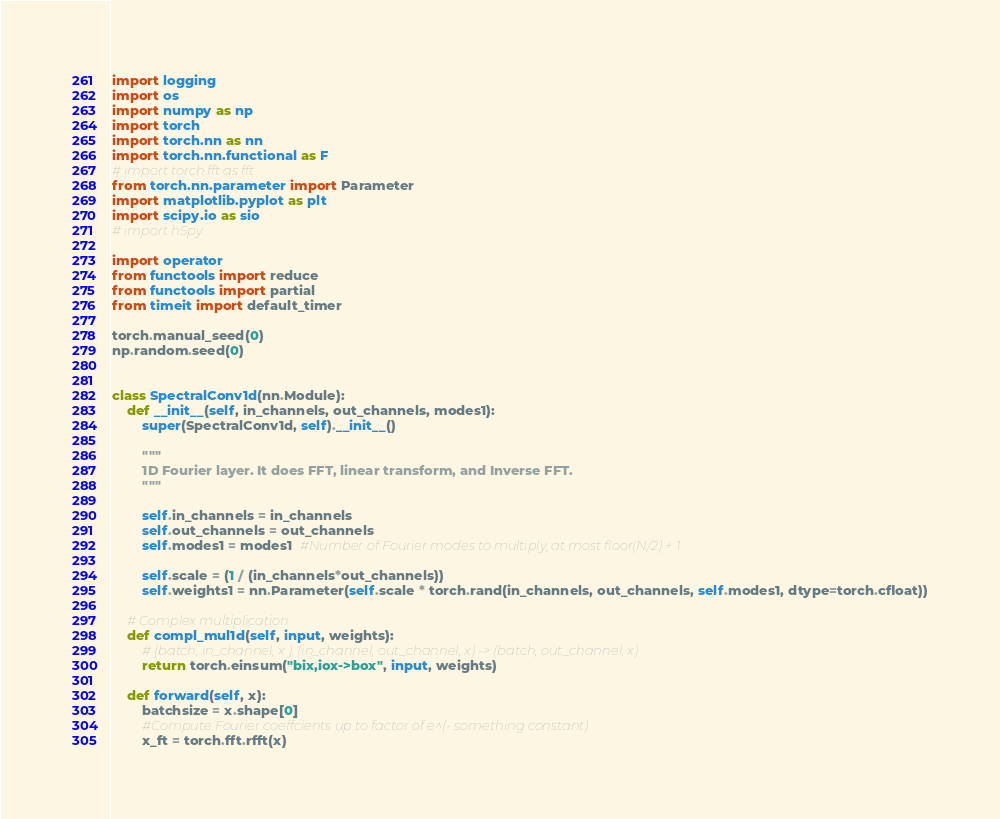<code> <loc_0><loc_0><loc_500><loc_500><_Python_>import logging
import os
import numpy as np
import torch
import torch.nn as nn
import torch.nn.functional as F
# import torch.fft as fft
from torch.nn.parameter import Parameter
import matplotlib.pyplot as plt
import scipy.io as sio
# import h5py

import operator
from functools import reduce
from functools import partial
from timeit import default_timer

torch.manual_seed(0)
np.random.seed(0)


class SpectralConv1d(nn.Module):
    def __init__(self, in_channels, out_channels, modes1):
        super(SpectralConv1d, self).__init__()

        """
        1D Fourier layer. It does FFT, linear transform, and Inverse FFT.
        """

        self.in_channels = in_channels
        self.out_channels = out_channels
        self.modes1 = modes1  #Number of Fourier modes to multiply, at most floor(N/2) + 1

        self.scale = (1 / (in_channels*out_channels))
        self.weights1 = nn.Parameter(self.scale * torch.rand(in_channels, out_channels, self.modes1, dtype=torch.cfloat))

    # Complex multiplication
    def compl_mul1d(self, input, weights):
        # (batch, in_channel, x ), (in_channel, out_channel, x) -> (batch, out_channel, x)
        return torch.einsum("bix,iox->box", input, weights)

    def forward(self, x):
        batchsize = x.shape[0]
        #Compute Fourier coeffcients up to factor of e^(- something constant)
        x_ft = torch.fft.rfft(x)
</code> 